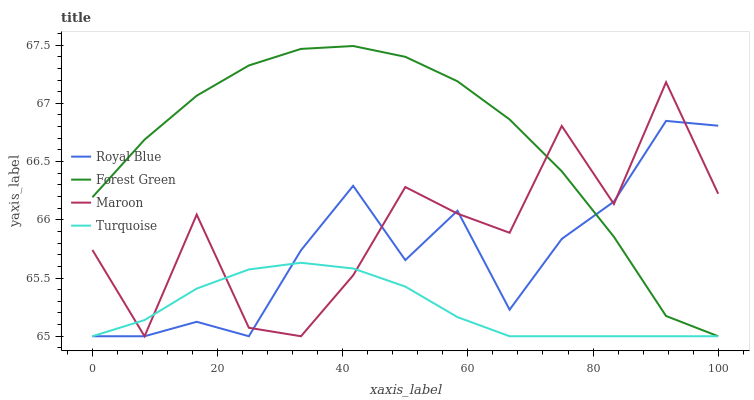Does Forest Green have the minimum area under the curve?
Answer yes or no. No. Does Turquoise have the maximum area under the curve?
Answer yes or no. No. Is Forest Green the smoothest?
Answer yes or no. No. Is Forest Green the roughest?
Answer yes or no. No. Does Turquoise have the highest value?
Answer yes or no. No. 